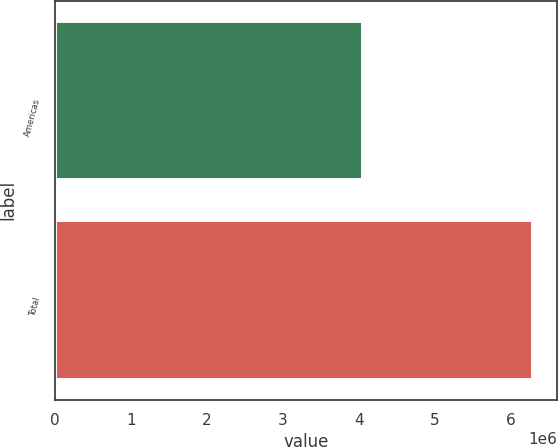<chart> <loc_0><loc_0><loc_500><loc_500><bar_chart><fcel>Americas<fcel>Total<nl><fcel>4.04909e+06<fcel>6.2882e+06<nl></chart> 